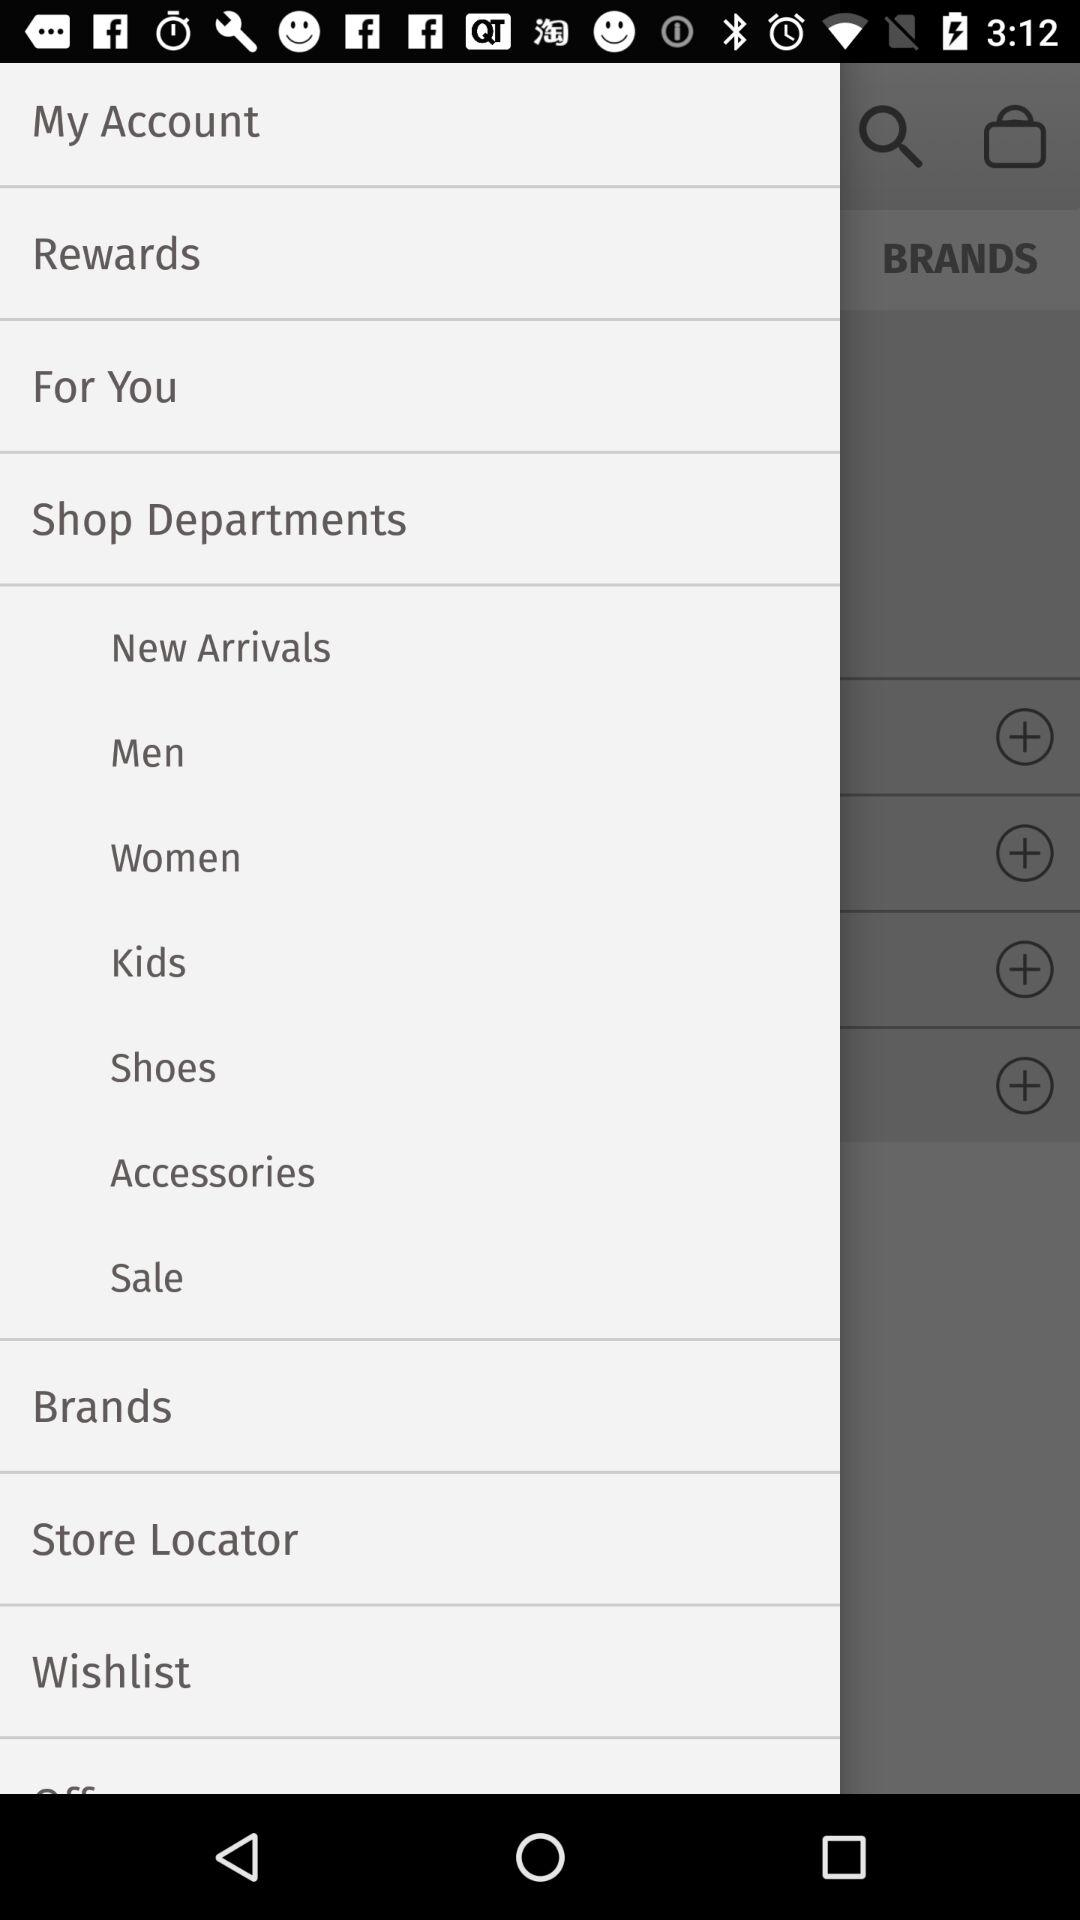What are the different available shop departments? The different available shop departments are "New Arrivals", "Men", "Women", "Kids", "Shoes", "Accessories" and "Sale". 